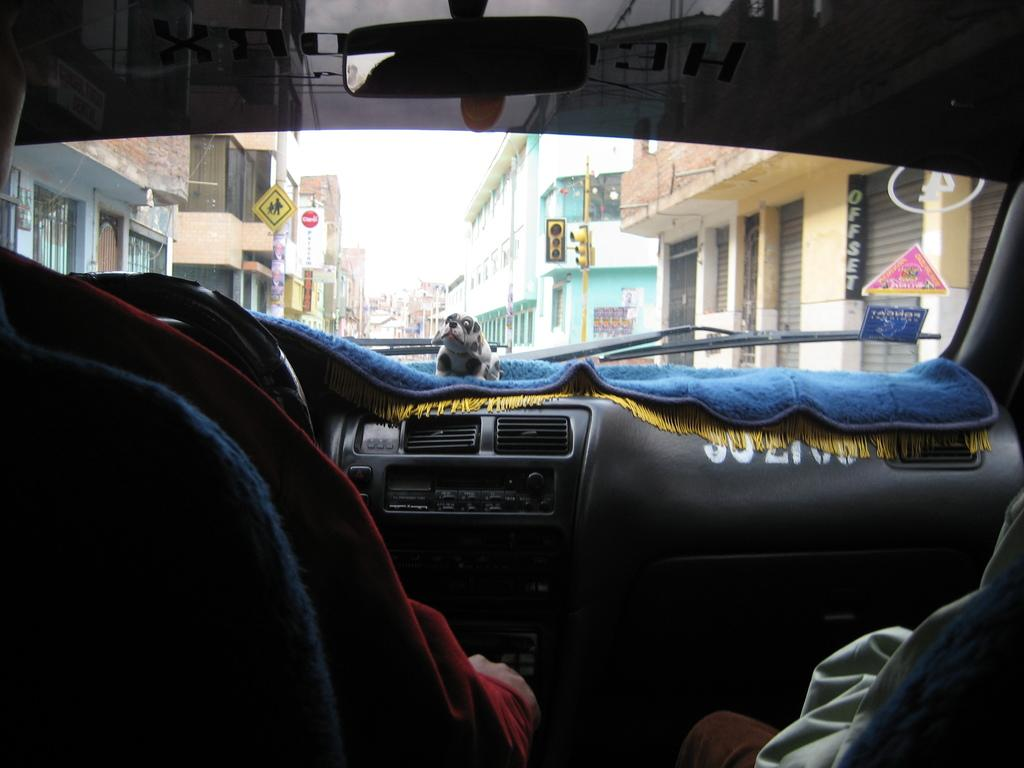Where was the image taken? The image was taken inside a car. Who is driving the car in the image? There is a person driving the car in the image. Who is sitting at the right side of the car? There is a person sitting at the right side of the car. What can be seen in the background of the image? There are buildings visible in the background of the image. What type of error can be seen on the person's chin in the image? There is no error visible on anyone's chin in the image. Is there a rifle present in the image? No, there is no rifle present in the image. 